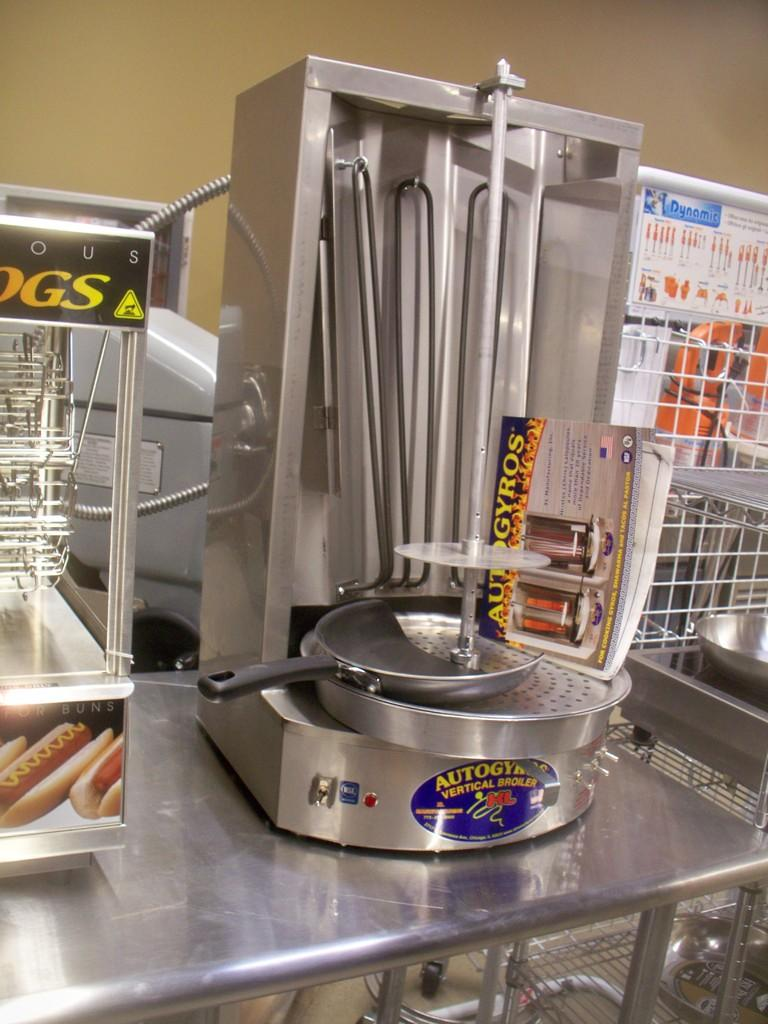Provide a one-sentence caption for the provided image. A hot dog cooker is next to a vertical hotdog broiler. 